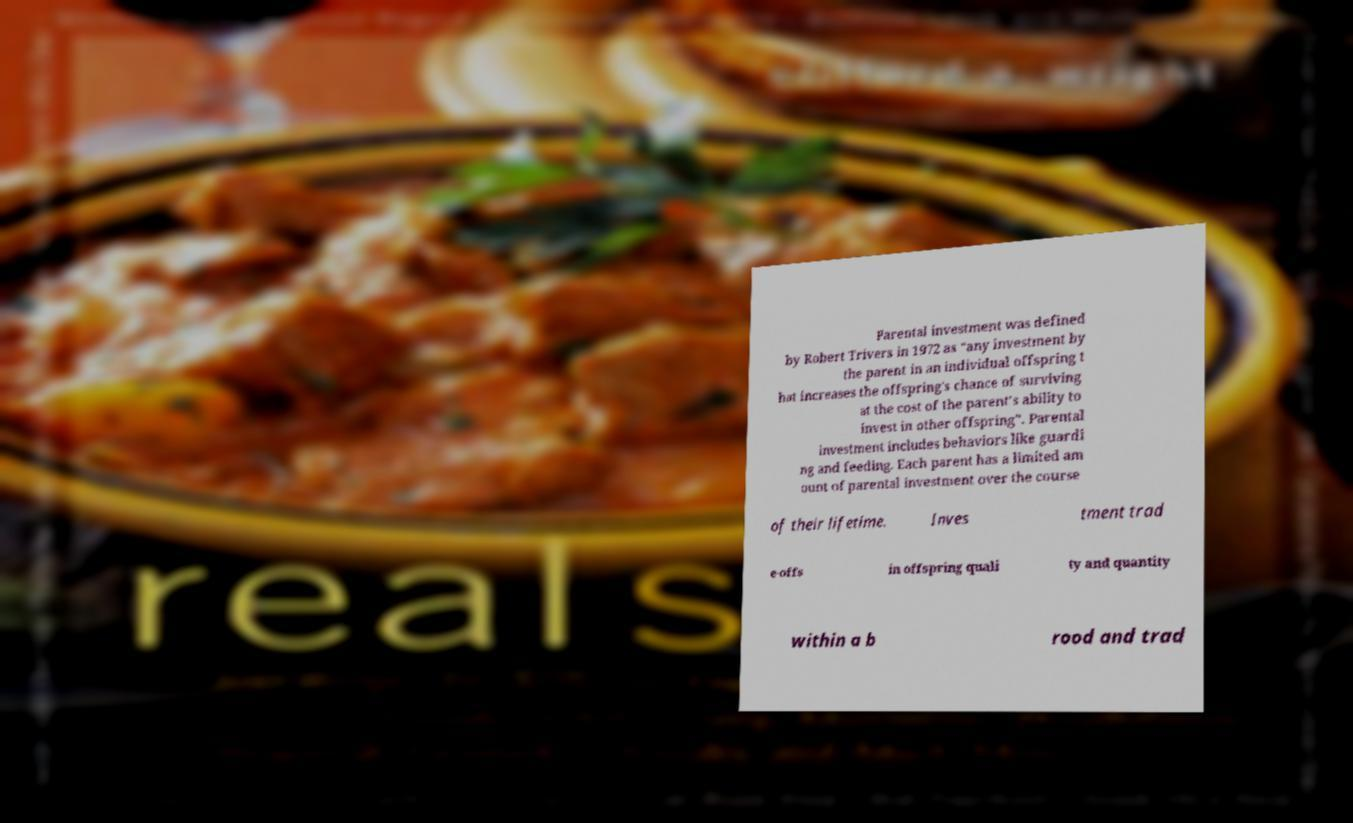I need the written content from this picture converted into text. Can you do that? Parental investment was defined by Robert Trivers in 1972 as “any investment by the parent in an individual offspring t hat increases the offspring's chance of surviving at the cost of the parent’s ability to invest in other offspring”. Parental investment includes behaviors like guardi ng and feeding. Each parent has a limited am ount of parental investment over the course of their lifetime. Inves tment trad e-offs in offspring quali ty and quantity within a b rood and trad 